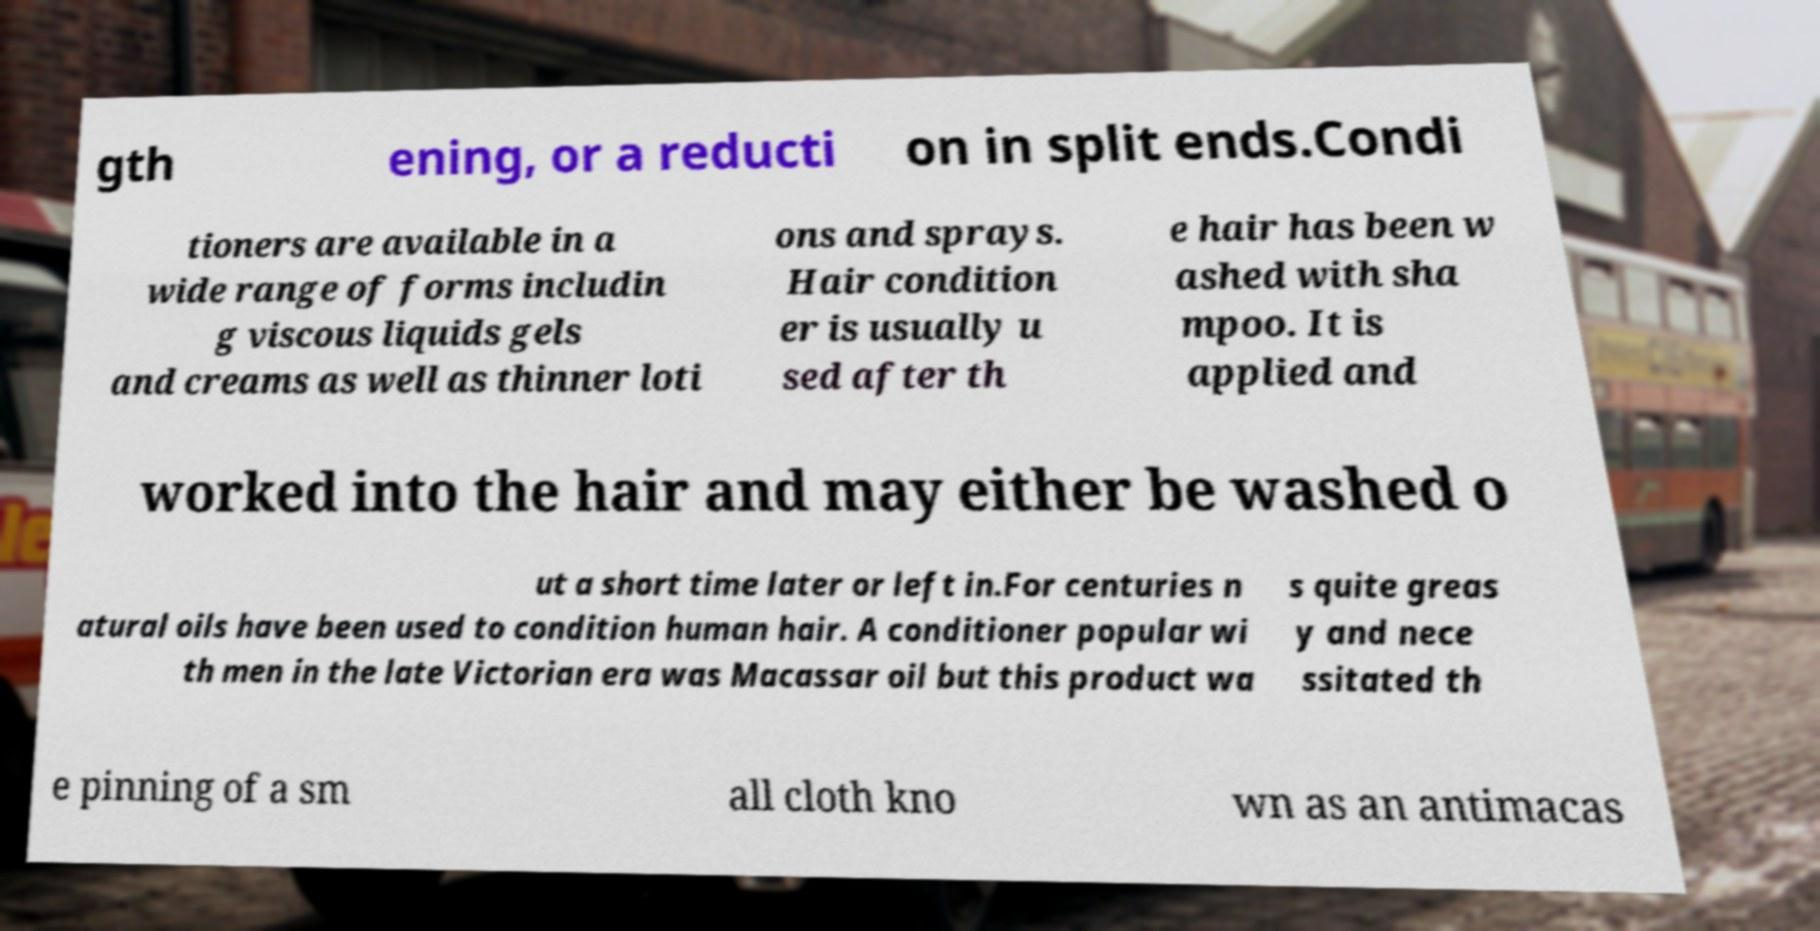I need the written content from this picture converted into text. Can you do that? gth ening, or a reducti on in split ends.Condi tioners are available in a wide range of forms includin g viscous liquids gels and creams as well as thinner loti ons and sprays. Hair condition er is usually u sed after th e hair has been w ashed with sha mpoo. It is applied and worked into the hair and may either be washed o ut a short time later or left in.For centuries n atural oils have been used to condition human hair. A conditioner popular wi th men in the late Victorian era was Macassar oil but this product wa s quite greas y and nece ssitated th e pinning of a sm all cloth kno wn as an antimacas 